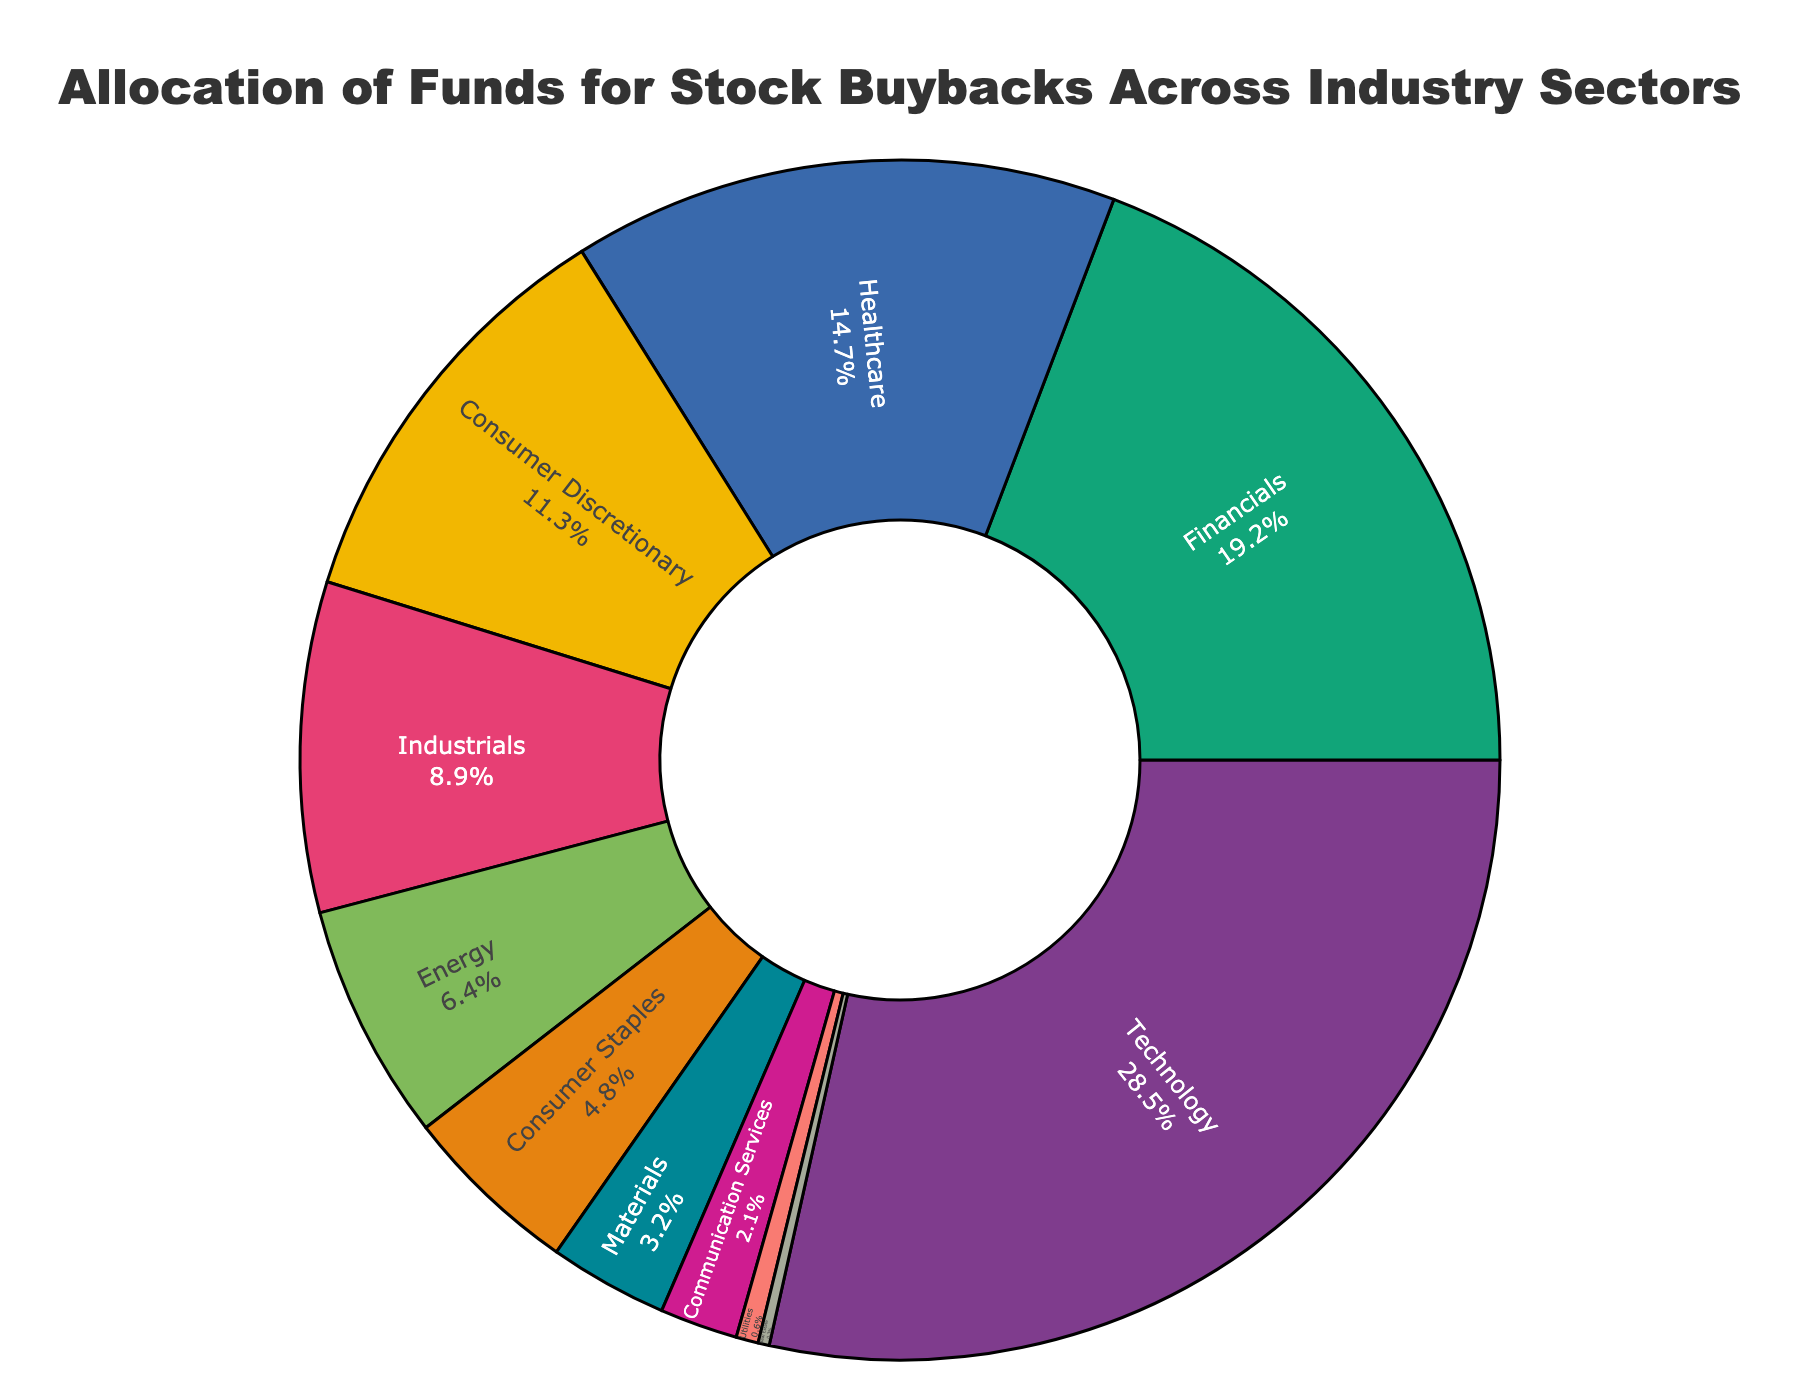What sector receives the largest allocation of funds for stock buybacks? The sector with the highest percentage in the pie chart receives the largest allocation. In this case, "Technology" has the highest percentage.
Answer: Technology What is the combined percentage of funds allocated to the Technology and Financials sectors? Add the percentages of the Technology and Financials sectors, which are 28.5% and 19.2%, respectively. The combined percentage is 28.5 + 19.2 = 47.7%.
Answer: 47.7% Which sector receives almost half the funds compared to the Technology sector? Compare the percentages in the pie chart and find a sector close to half of 28.5%, which is approximately 14.25%. "Healthcare" has 14.7%, which is nearest.
Answer: Healthcare How does the allocation to Energy compare with that to Consumer Staples? Look at the percentages for both sectors in the pie chart. Energy has 6.4%, and Consumer Staples has 4.8%. Energy receives more funds than Consumer Staples.
Answer: Energy receives more If we add the allocations of Consumer Discretionary, Industrials, and Energy, what is the total percentage? Add the percentages of Consumer Discretionary (11.3%), Industrials (8.9%), and Energy (6.4%). The result is 11.3 + 8.9 + 6.4 = 26.6%.
Answer: 26.6% Which sector has the smallest allocation of funds? Identify the sector with the lowest percentage in the pie chart. "Real Estate" has the smallest allocation at 0.3%.
Answer: Real Estate What is the difference in percentage allocation between the Consumer Discretionary and Communication Services sectors? Subtract the percentage of Communication Services (2.1%) from Consumer Discretionary (11.3%). The difference is 11.3 - 2.1 = 9.2%.
Answer: 9.2% Is the allocation to Healthcare greater than the combined allocation of Utilities and Real Estate? Compare the percentage of Healthcare (14.7%) to the sum of Utilities (0.6%) and Real Estate (0.3%), which is 0.6 + 0.3 = 0.9%. 14.7% is greater than 0.9%.
Answer: Yes What is the average percentage allocation of funds across all sectors? Calculate the average by summing all percentages and dividing by the number of sectors. The total is 28.5 + 19.2 + 14.7 + 11.3 + 8.9 + 6.4 + 4.8 + 3.2 + 2.1 + 0.6 + 0.3 = 100%, and there are 11 sectors. The average is 100 / 11 ≈ 9.09%.
Answer: 9.09% Which two sectors together account for about one-third of the total allocation? Look for two sectors whose combined percentage is close to 33.33%. Technology (28.5%) and Real Estate (0.3%) together sum up to 28.8%, which is not sufficient. Technology (28.5%) and Energy (6.4%) together sum up to 34.9%, which is close enough.
Answer: Technology and Energy 